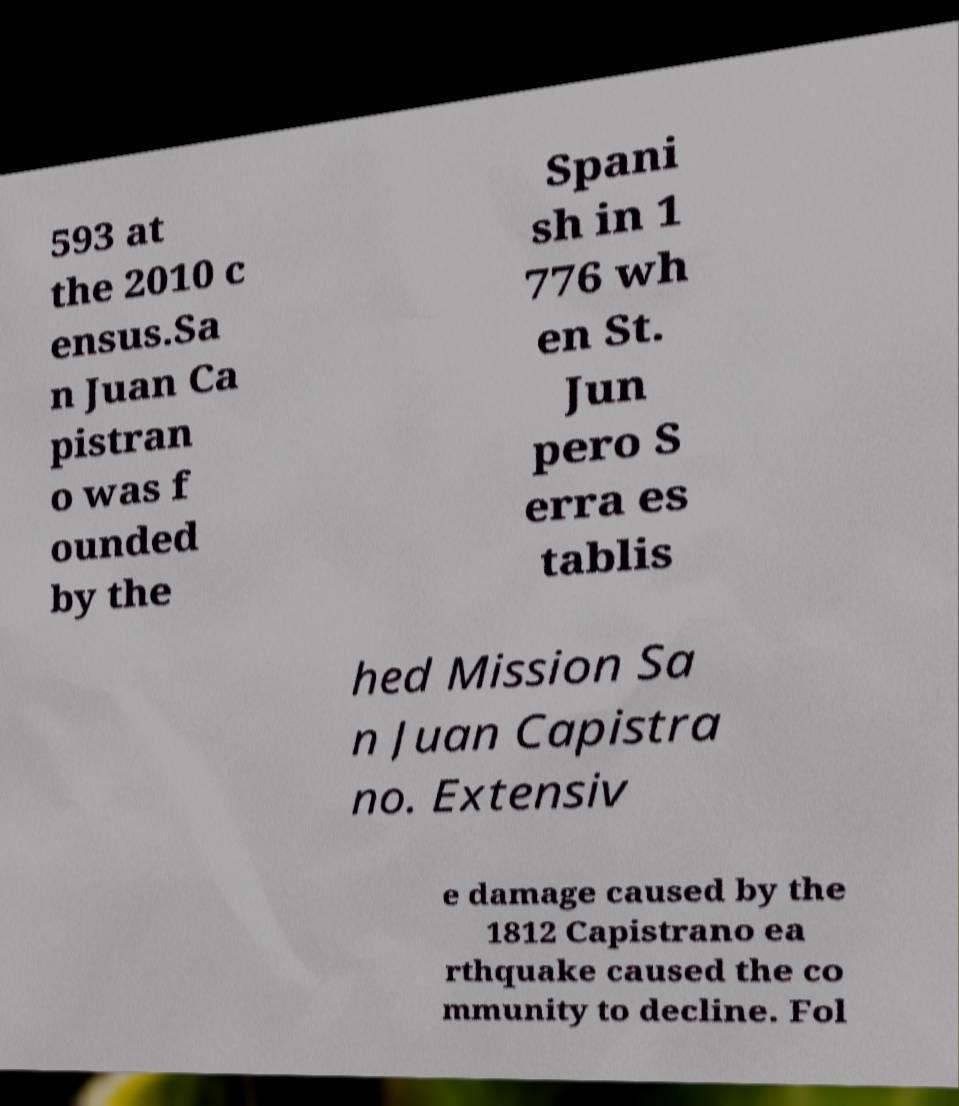Please read and relay the text visible in this image. What does it say? 593 at the 2010 c ensus.Sa n Juan Ca pistran o was f ounded by the Spani sh in 1 776 wh en St. Jun pero S erra es tablis hed Mission Sa n Juan Capistra no. Extensiv e damage caused by the 1812 Capistrano ea rthquake caused the co mmunity to decline. Fol 